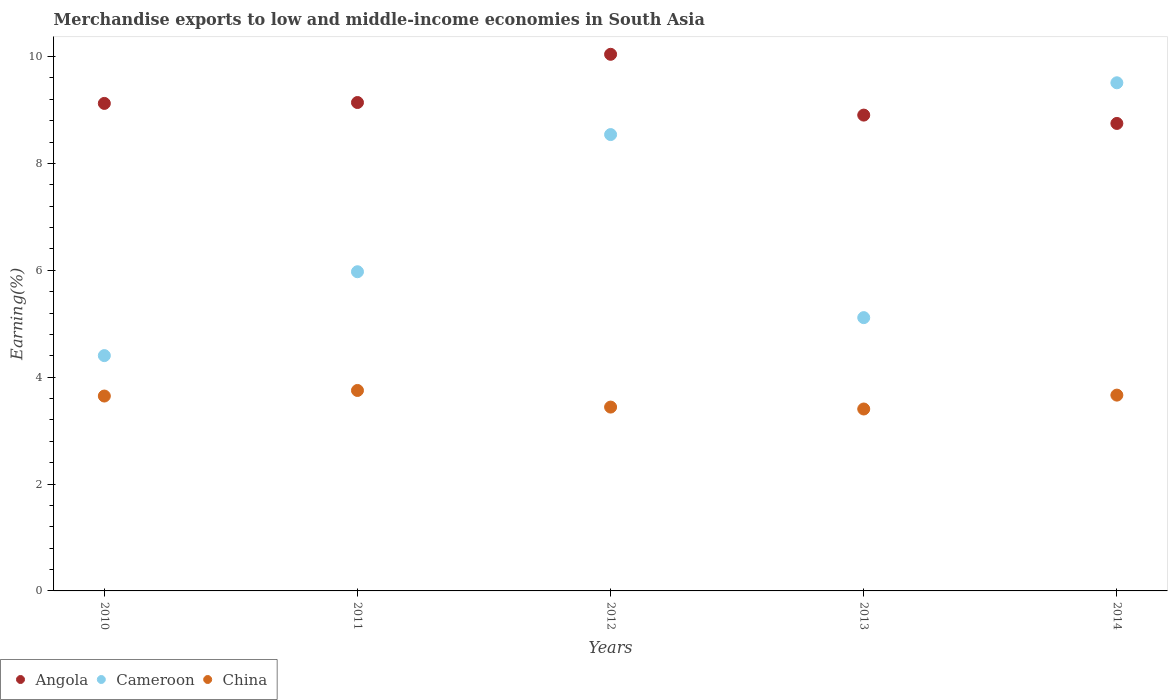How many different coloured dotlines are there?
Provide a short and direct response. 3. What is the percentage of amount earned from merchandise exports in China in 2014?
Keep it short and to the point. 3.66. Across all years, what is the maximum percentage of amount earned from merchandise exports in China?
Provide a succinct answer. 3.75. Across all years, what is the minimum percentage of amount earned from merchandise exports in China?
Your answer should be compact. 3.4. In which year was the percentage of amount earned from merchandise exports in Cameroon maximum?
Your answer should be very brief. 2014. In which year was the percentage of amount earned from merchandise exports in China minimum?
Offer a terse response. 2013. What is the total percentage of amount earned from merchandise exports in Cameroon in the graph?
Your response must be concise. 33.54. What is the difference between the percentage of amount earned from merchandise exports in China in 2011 and that in 2012?
Offer a very short reply. 0.31. What is the difference between the percentage of amount earned from merchandise exports in Angola in 2011 and the percentage of amount earned from merchandise exports in China in 2010?
Your answer should be compact. 5.49. What is the average percentage of amount earned from merchandise exports in China per year?
Your answer should be very brief. 3.58. In the year 2014, what is the difference between the percentage of amount earned from merchandise exports in China and percentage of amount earned from merchandise exports in Cameroon?
Provide a succinct answer. -5.85. What is the ratio of the percentage of amount earned from merchandise exports in China in 2010 to that in 2014?
Your answer should be compact. 1. What is the difference between the highest and the second highest percentage of amount earned from merchandise exports in Cameroon?
Your response must be concise. 0.97. What is the difference between the highest and the lowest percentage of amount earned from merchandise exports in Angola?
Your answer should be compact. 1.29. Is the sum of the percentage of amount earned from merchandise exports in China in 2012 and 2013 greater than the maximum percentage of amount earned from merchandise exports in Cameroon across all years?
Your answer should be very brief. No. Is it the case that in every year, the sum of the percentage of amount earned from merchandise exports in Cameroon and percentage of amount earned from merchandise exports in Angola  is greater than the percentage of amount earned from merchandise exports in China?
Ensure brevity in your answer.  Yes. Is the percentage of amount earned from merchandise exports in Angola strictly greater than the percentage of amount earned from merchandise exports in Cameroon over the years?
Provide a short and direct response. No. Is the percentage of amount earned from merchandise exports in Cameroon strictly less than the percentage of amount earned from merchandise exports in China over the years?
Provide a short and direct response. No. How many years are there in the graph?
Offer a very short reply. 5. What is the difference between two consecutive major ticks on the Y-axis?
Make the answer very short. 2. Does the graph contain grids?
Provide a short and direct response. No. What is the title of the graph?
Your answer should be very brief. Merchandise exports to low and middle-income economies in South Asia. Does "United Kingdom" appear as one of the legend labels in the graph?
Make the answer very short. No. What is the label or title of the Y-axis?
Ensure brevity in your answer.  Earning(%). What is the Earning(%) of Angola in 2010?
Ensure brevity in your answer.  9.12. What is the Earning(%) of Cameroon in 2010?
Provide a short and direct response. 4.4. What is the Earning(%) of China in 2010?
Your response must be concise. 3.65. What is the Earning(%) of Angola in 2011?
Make the answer very short. 9.14. What is the Earning(%) of Cameroon in 2011?
Offer a very short reply. 5.97. What is the Earning(%) in China in 2011?
Make the answer very short. 3.75. What is the Earning(%) of Angola in 2012?
Give a very brief answer. 10.04. What is the Earning(%) of Cameroon in 2012?
Give a very brief answer. 8.54. What is the Earning(%) in China in 2012?
Make the answer very short. 3.44. What is the Earning(%) of Angola in 2013?
Make the answer very short. 8.9. What is the Earning(%) of Cameroon in 2013?
Offer a terse response. 5.11. What is the Earning(%) in China in 2013?
Your response must be concise. 3.4. What is the Earning(%) in Angola in 2014?
Provide a short and direct response. 8.75. What is the Earning(%) in Cameroon in 2014?
Your response must be concise. 9.51. What is the Earning(%) of China in 2014?
Give a very brief answer. 3.66. Across all years, what is the maximum Earning(%) in Angola?
Your answer should be compact. 10.04. Across all years, what is the maximum Earning(%) of Cameroon?
Ensure brevity in your answer.  9.51. Across all years, what is the maximum Earning(%) of China?
Your answer should be very brief. 3.75. Across all years, what is the minimum Earning(%) of Angola?
Provide a short and direct response. 8.75. Across all years, what is the minimum Earning(%) of Cameroon?
Provide a short and direct response. 4.4. Across all years, what is the minimum Earning(%) of China?
Offer a terse response. 3.4. What is the total Earning(%) in Angola in the graph?
Provide a short and direct response. 45.96. What is the total Earning(%) of Cameroon in the graph?
Give a very brief answer. 33.54. What is the total Earning(%) in China in the graph?
Offer a very short reply. 17.91. What is the difference between the Earning(%) of Angola in 2010 and that in 2011?
Your response must be concise. -0.02. What is the difference between the Earning(%) in Cameroon in 2010 and that in 2011?
Provide a short and direct response. -1.57. What is the difference between the Earning(%) of China in 2010 and that in 2011?
Your answer should be compact. -0.1. What is the difference between the Earning(%) of Angola in 2010 and that in 2012?
Offer a very short reply. -0.92. What is the difference between the Earning(%) of Cameroon in 2010 and that in 2012?
Provide a short and direct response. -4.14. What is the difference between the Earning(%) in China in 2010 and that in 2012?
Your response must be concise. 0.21. What is the difference between the Earning(%) of Angola in 2010 and that in 2013?
Keep it short and to the point. 0.22. What is the difference between the Earning(%) in Cameroon in 2010 and that in 2013?
Provide a succinct answer. -0.71. What is the difference between the Earning(%) in China in 2010 and that in 2013?
Ensure brevity in your answer.  0.24. What is the difference between the Earning(%) of Angola in 2010 and that in 2014?
Offer a terse response. 0.37. What is the difference between the Earning(%) of Cameroon in 2010 and that in 2014?
Provide a succinct answer. -5.11. What is the difference between the Earning(%) in China in 2010 and that in 2014?
Make the answer very short. -0.02. What is the difference between the Earning(%) in Angola in 2011 and that in 2012?
Your response must be concise. -0.9. What is the difference between the Earning(%) in Cameroon in 2011 and that in 2012?
Provide a short and direct response. -2.57. What is the difference between the Earning(%) in China in 2011 and that in 2012?
Keep it short and to the point. 0.31. What is the difference between the Earning(%) of Angola in 2011 and that in 2013?
Make the answer very short. 0.24. What is the difference between the Earning(%) in Cameroon in 2011 and that in 2013?
Provide a succinct answer. 0.86. What is the difference between the Earning(%) in China in 2011 and that in 2013?
Offer a very short reply. 0.35. What is the difference between the Earning(%) in Angola in 2011 and that in 2014?
Make the answer very short. 0.39. What is the difference between the Earning(%) of Cameroon in 2011 and that in 2014?
Make the answer very short. -3.54. What is the difference between the Earning(%) in China in 2011 and that in 2014?
Ensure brevity in your answer.  0.09. What is the difference between the Earning(%) of Angola in 2012 and that in 2013?
Provide a succinct answer. 1.14. What is the difference between the Earning(%) of Cameroon in 2012 and that in 2013?
Your answer should be very brief. 3.43. What is the difference between the Earning(%) in China in 2012 and that in 2013?
Keep it short and to the point. 0.04. What is the difference between the Earning(%) of Angola in 2012 and that in 2014?
Provide a succinct answer. 1.29. What is the difference between the Earning(%) in Cameroon in 2012 and that in 2014?
Give a very brief answer. -0.97. What is the difference between the Earning(%) in China in 2012 and that in 2014?
Make the answer very short. -0.22. What is the difference between the Earning(%) in Angola in 2013 and that in 2014?
Your answer should be compact. 0.16. What is the difference between the Earning(%) of Cameroon in 2013 and that in 2014?
Give a very brief answer. -4.4. What is the difference between the Earning(%) in China in 2013 and that in 2014?
Offer a very short reply. -0.26. What is the difference between the Earning(%) of Angola in 2010 and the Earning(%) of Cameroon in 2011?
Keep it short and to the point. 3.15. What is the difference between the Earning(%) in Angola in 2010 and the Earning(%) in China in 2011?
Offer a very short reply. 5.37. What is the difference between the Earning(%) in Cameroon in 2010 and the Earning(%) in China in 2011?
Provide a succinct answer. 0.65. What is the difference between the Earning(%) in Angola in 2010 and the Earning(%) in Cameroon in 2012?
Ensure brevity in your answer.  0.58. What is the difference between the Earning(%) in Angola in 2010 and the Earning(%) in China in 2012?
Your answer should be very brief. 5.68. What is the difference between the Earning(%) in Cameroon in 2010 and the Earning(%) in China in 2012?
Ensure brevity in your answer.  0.96. What is the difference between the Earning(%) of Angola in 2010 and the Earning(%) of Cameroon in 2013?
Keep it short and to the point. 4.01. What is the difference between the Earning(%) of Angola in 2010 and the Earning(%) of China in 2013?
Offer a terse response. 5.72. What is the difference between the Earning(%) in Cameroon in 2010 and the Earning(%) in China in 2013?
Make the answer very short. 1. What is the difference between the Earning(%) of Angola in 2010 and the Earning(%) of Cameroon in 2014?
Keep it short and to the point. -0.39. What is the difference between the Earning(%) in Angola in 2010 and the Earning(%) in China in 2014?
Your response must be concise. 5.46. What is the difference between the Earning(%) in Cameroon in 2010 and the Earning(%) in China in 2014?
Your answer should be compact. 0.74. What is the difference between the Earning(%) of Angola in 2011 and the Earning(%) of Cameroon in 2012?
Provide a short and direct response. 0.6. What is the difference between the Earning(%) of Angola in 2011 and the Earning(%) of China in 2012?
Offer a terse response. 5.7. What is the difference between the Earning(%) in Cameroon in 2011 and the Earning(%) in China in 2012?
Your answer should be very brief. 2.53. What is the difference between the Earning(%) in Angola in 2011 and the Earning(%) in Cameroon in 2013?
Provide a succinct answer. 4.03. What is the difference between the Earning(%) in Angola in 2011 and the Earning(%) in China in 2013?
Your response must be concise. 5.74. What is the difference between the Earning(%) in Cameroon in 2011 and the Earning(%) in China in 2013?
Offer a terse response. 2.57. What is the difference between the Earning(%) of Angola in 2011 and the Earning(%) of Cameroon in 2014?
Make the answer very short. -0.37. What is the difference between the Earning(%) in Angola in 2011 and the Earning(%) in China in 2014?
Make the answer very short. 5.48. What is the difference between the Earning(%) in Cameroon in 2011 and the Earning(%) in China in 2014?
Keep it short and to the point. 2.31. What is the difference between the Earning(%) in Angola in 2012 and the Earning(%) in Cameroon in 2013?
Offer a very short reply. 4.93. What is the difference between the Earning(%) of Angola in 2012 and the Earning(%) of China in 2013?
Make the answer very short. 6.64. What is the difference between the Earning(%) in Cameroon in 2012 and the Earning(%) in China in 2013?
Your response must be concise. 5.14. What is the difference between the Earning(%) of Angola in 2012 and the Earning(%) of Cameroon in 2014?
Offer a very short reply. 0.53. What is the difference between the Earning(%) in Angola in 2012 and the Earning(%) in China in 2014?
Your response must be concise. 6.38. What is the difference between the Earning(%) of Cameroon in 2012 and the Earning(%) of China in 2014?
Your answer should be very brief. 4.88. What is the difference between the Earning(%) in Angola in 2013 and the Earning(%) in Cameroon in 2014?
Provide a succinct answer. -0.6. What is the difference between the Earning(%) in Angola in 2013 and the Earning(%) in China in 2014?
Ensure brevity in your answer.  5.24. What is the difference between the Earning(%) of Cameroon in 2013 and the Earning(%) of China in 2014?
Offer a very short reply. 1.45. What is the average Earning(%) in Angola per year?
Give a very brief answer. 9.19. What is the average Earning(%) in Cameroon per year?
Offer a terse response. 6.71. What is the average Earning(%) of China per year?
Your answer should be compact. 3.58. In the year 2010, what is the difference between the Earning(%) of Angola and Earning(%) of Cameroon?
Provide a succinct answer. 4.72. In the year 2010, what is the difference between the Earning(%) in Angola and Earning(%) in China?
Keep it short and to the point. 5.48. In the year 2010, what is the difference between the Earning(%) in Cameroon and Earning(%) in China?
Provide a short and direct response. 0.76. In the year 2011, what is the difference between the Earning(%) of Angola and Earning(%) of Cameroon?
Your answer should be very brief. 3.17. In the year 2011, what is the difference between the Earning(%) in Angola and Earning(%) in China?
Your answer should be very brief. 5.39. In the year 2011, what is the difference between the Earning(%) of Cameroon and Earning(%) of China?
Keep it short and to the point. 2.22. In the year 2012, what is the difference between the Earning(%) in Angola and Earning(%) in Cameroon?
Your response must be concise. 1.5. In the year 2012, what is the difference between the Earning(%) in Angola and Earning(%) in China?
Your answer should be very brief. 6.6. In the year 2012, what is the difference between the Earning(%) in Cameroon and Earning(%) in China?
Your response must be concise. 5.1. In the year 2013, what is the difference between the Earning(%) of Angola and Earning(%) of Cameroon?
Ensure brevity in your answer.  3.79. In the year 2013, what is the difference between the Earning(%) of Angola and Earning(%) of China?
Provide a succinct answer. 5.5. In the year 2013, what is the difference between the Earning(%) of Cameroon and Earning(%) of China?
Your response must be concise. 1.71. In the year 2014, what is the difference between the Earning(%) in Angola and Earning(%) in Cameroon?
Your response must be concise. -0.76. In the year 2014, what is the difference between the Earning(%) in Angola and Earning(%) in China?
Your response must be concise. 5.08. In the year 2014, what is the difference between the Earning(%) of Cameroon and Earning(%) of China?
Make the answer very short. 5.85. What is the ratio of the Earning(%) in Cameroon in 2010 to that in 2011?
Provide a short and direct response. 0.74. What is the ratio of the Earning(%) in China in 2010 to that in 2011?
Provide a short and direct response. 0.97. What is the ratio of the Earning(%) in Angola in 2010 to that in 2012?
Keep it short and to the point. 0.91. What is the ratio of the Earning(%) of Cameroon in 2010 to that in 2012?
Your answer should be compact. 0.52. What is the ratio of the Earning(%) of China in 2010 to that in 2012?
Offer a very short reply. 1.06. What is the ratio of the Earning(%) of Angola in 2010 to that in 2013?
Keep it short and to the point. 1.02. What is the ratio of the Earning(%) of Cameroon in 2010 to that in 2013?
Keep it short and to the point. 0.86. What is the ratio of the Earning(%) in China in 2010 to that in 2013?
Provide a short and direct response. 1.07. What is the ratio of the Earning(%) of Angola in 2010 to that in 2014?
Provide a succinct answer. 1.04. What is the ratio of the Earning(%) in Cameroon in 2010 to that in 2014?
Offer a very short reply. 0.46. What is the ratio of the Earning(%) in Angola in 2011 to that in 2012?
Ensure brevity in your answer.  0.91. What is the ratio of the Earning(%) of Cameroon in 2011 to that in 2012?
Your response must be concise. 0.7. What is the ratio of the Earning(%) of China in 2011 to that in 2012?
Your answer should be compact. 1.09. What is the ratio of the Earning(%) of Angola in 2011 to that in 2013?
Your answer should be very brief. 1.03. What is the ratio of the Earning(%) of Cameroon in 2011 to that in 2013?
Offer a very short reply. 1.17. What is the ratio of the Earning(%) in China in 2011 to that in 2013?
Your answer should be compact. 1.1. What is the ratio of the Earning(%) in Angola in 2011 to that in 2014?
Your response must be concise. 1.04. What is the ratio of the Earning(%) of Cameroon in 2011 to that in 2014?
Provide a succinct answer. 0.63. What is the ratio of the Earning(%) in China in 2011 to that in 2014?
Make the answer very short. 1.02. What is the ratio of the Earning(%) of Angola in 2012 to that in 2013?
Keep it short and to the point. 1.13. What is the ratio of the Earning(%) in Cameroon in 2012 to that in 2013?
Provide a short and direct response. 1.67. What is the ratio of the Earning(%) in China in 2012 to that in 2013?
Provide a succinct answer. 1.01. What is the ratio of the Earning(%) in Angola in 2012 to that in 2014?
Offer a terse response. 1.15. What is the ratio of the Earning(%) in Cameroon in 2012 to that in 2014?
Give a very brief answer. 0.9. What is the ratio of the Earning(%) of China in 2012 to that in 2014?
Give a very brief answer. 0.94. What is the ratio of the Earning(%) of Angola in 2013 to that in 2014?
Provide a succinct answer. 1.02. What is the ratio of the Earning(%) in Cameroon in 2013 to that in 2014?
Offer a very short reply. 0.54. What is the ratio of the Earning(%) of China in 2013 to that in 2014?
Ensure brevity in your answer.  0.93. What is the difference between the highest and the second highest Earning(%) of Angola?
Offer a very short reply. 0.9. What is the difference between the highest and the second highest Earning(%) in Cameroon?
Your answer should be compact. 0.97. What is the difference between the highest and the second highest Earning(%) of China?
Provide a short and direct response. 0.09. What is the difference between the highest and the lowest Earning(%) in Angola?
Make the answer very short. 1.29. What is the difference between the highest and the lowest Earning(%) in Cameroon?
Offer a terse response. 5.11. What is the difference between the highest and the lowest Earning(%) in China?
Offer a very short reply. 0.35. 